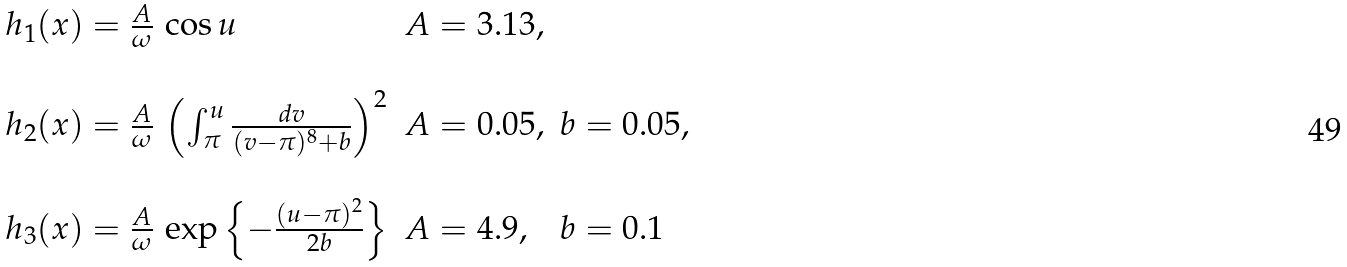Convert formula to latex. <formula><loc_0><loc_0><loc_500><loc_500>\begin{array} { l l l } h _ { 1 } ( x ) = \frac { A } { \omega } \, \cos u & A = 3 . 1 3 , & \\ & & \\ h _ { 2 } ( x ) = \frac { A } { \omega } \, \left ( \int ^ { u } _ { \pi } \frac { d v } { ( v - \pi ) ^ { 8 } + b } \right ) ^ { 2 } & A = 0 . 0 5 , & b = 0 . 0 5 , \\ & & \\ h _ { 3 } ( x ) = \frac { A } { \omega } \, \exp \left \{ - \frac { ( u - \pi ) ^ { 2 } } { 2 b } \right \} & A = 4 . 9 , & b = 0 . 1 \end{array}</formula> 